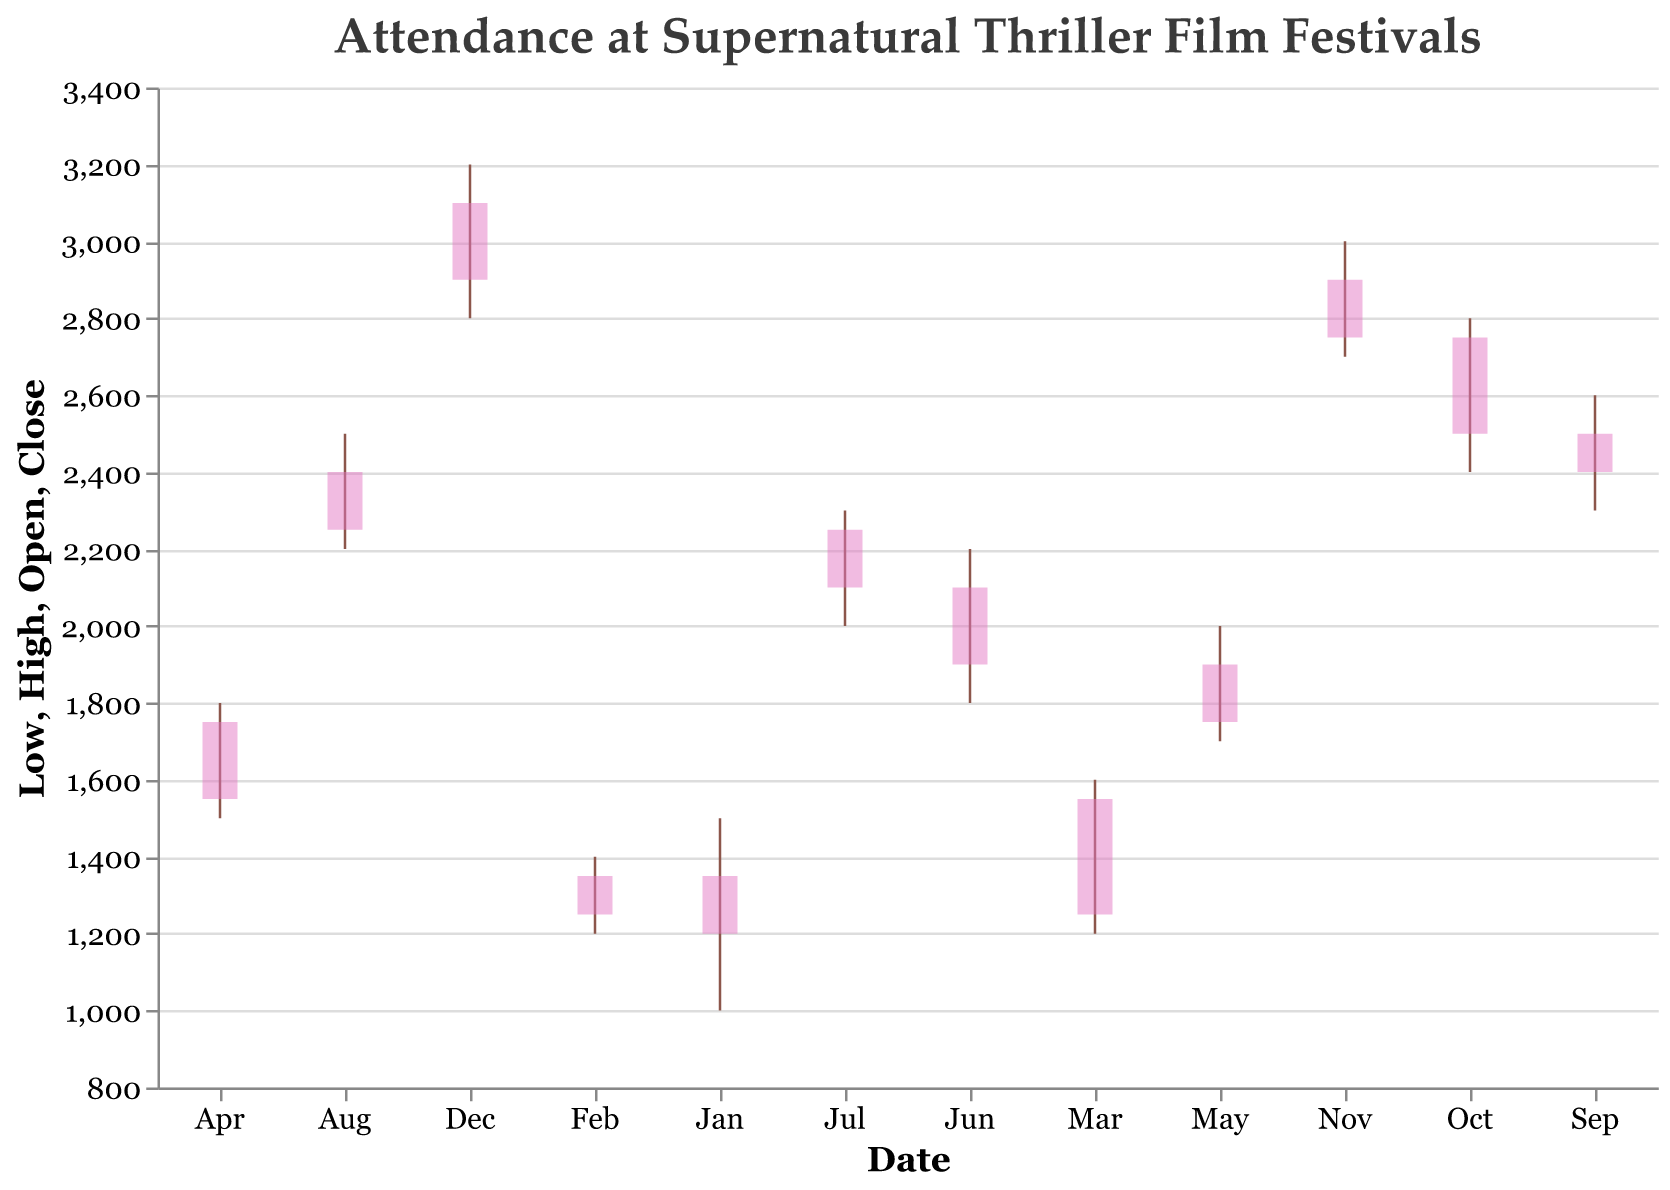What is the title of the figure? The title is located at the top of the figure and reads "Attendance at Supernatural Thriller Film Festivals".
Answer: Attendance at Supernatural Thriller Film Festivals Which month recorded the lowest attendance? The lowest attendance can be found by looking at the lowest 'Low' value. The lowest value is 1000 in January.
Answer: January How did the attendance change from January to February? The attendance opened at 1200 and closed at 1350 in January. In February, it opened at 1350 and closed at 1250.
Answer: It decreased What was the highest attendance recorded in July? The highest attendance in July is indicated by the 'High' value for July, which is 2300.
Answer: 2300 Was the attendance in October higher than in April? October's closing attendance is 2750, and April's is 1750. Comparing these values shows that October's attendance was higher.
Answer: Yes What was the average closing attendance from June to August? The closing attendances for June, July, and August are 2100, 2250, and 2400, respectively. The average is calculated as (2100 + 2250 + 2400) / 3 = 6750 / 3.
Answer: 2250 Which month experienced the highest closing attendance? The highest closing attendance is 3100, which was recorded in December.
Answer: December Compare the opening and closing attendance in March. Did it increase or decrease? In March, the opening attendance was 1250 and the closing attendance was 1550. The closing attendance being higher indicates an increase.
Answer: Increased What is the median opening attendance for the year? To find the median, list the opening attendances in order: 1200, 1250, 1350, 1550, 1750, 1900, 2100, 2250, 2400, 2500, 2750, 2900. The median is the average of the 6th and 7th values (1900, 2100). (1900 + 2100) / 2 = 2000.
Answer: 2000 Identify the month when attendance was most volatile, i.e., the largest difference between high and low attendances. The difference between high and low attendances needs to be calculated for all months. The month with the largest difference is October, with a difference of 400 (2800 - 2400).
Answer: October 